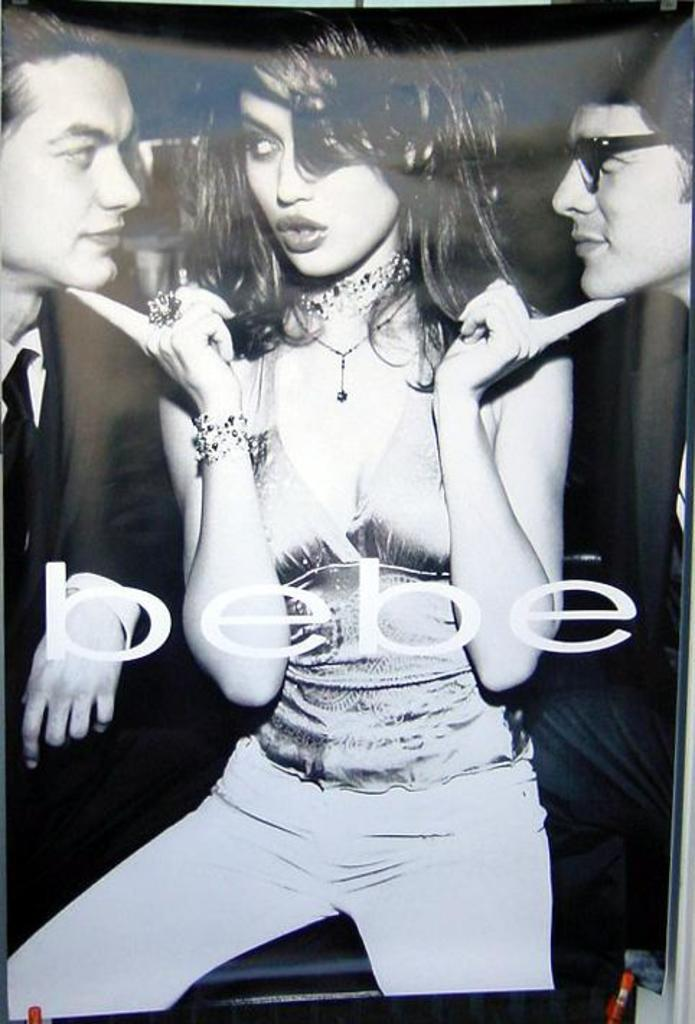What is the color scheme of the image? The image is black and white. What can be seen in the image besides the color scheme? There is a poster in the image. Who or what is depicted on the poster? The poster features a woman and two men. Is there any text on the poster? Yes, there is text on the poster. How many houses are visible in the image? There are no houses visible in the image; it features a black and white poster with a woman and two men. Can you describe the face of the woman on the poster? There is no face visible on the poster, as the image is black and white and the woman's features are not discernible. 